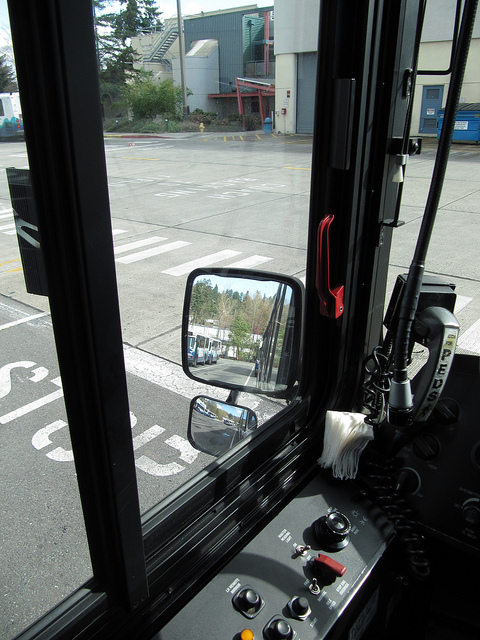<image>What is the bus driver wearing? I don't know what the bus driver is wearing. It could be a uniform. What is the bus driver wearing? I don't know what the bus driver is wearing. It can be a uniform, shirt or clothes. 